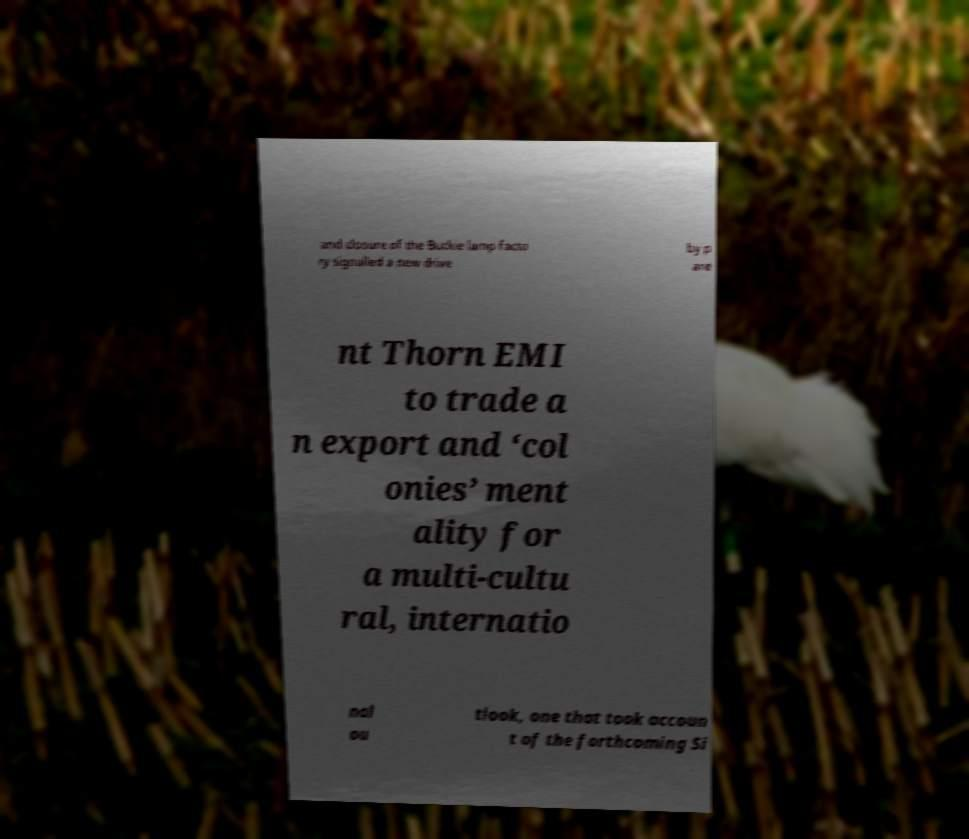What messages or text are displayed in this image? I need them in a readable, typed format. and closure of the Buckie lamp facto ry signalled a new drive by p are nt Thorn EMI to trade a n export and ‘col onies’ ment ality for a multi-cultu ral, internatio nal ou tlook, one that took accoun t of the forthcoming Si 